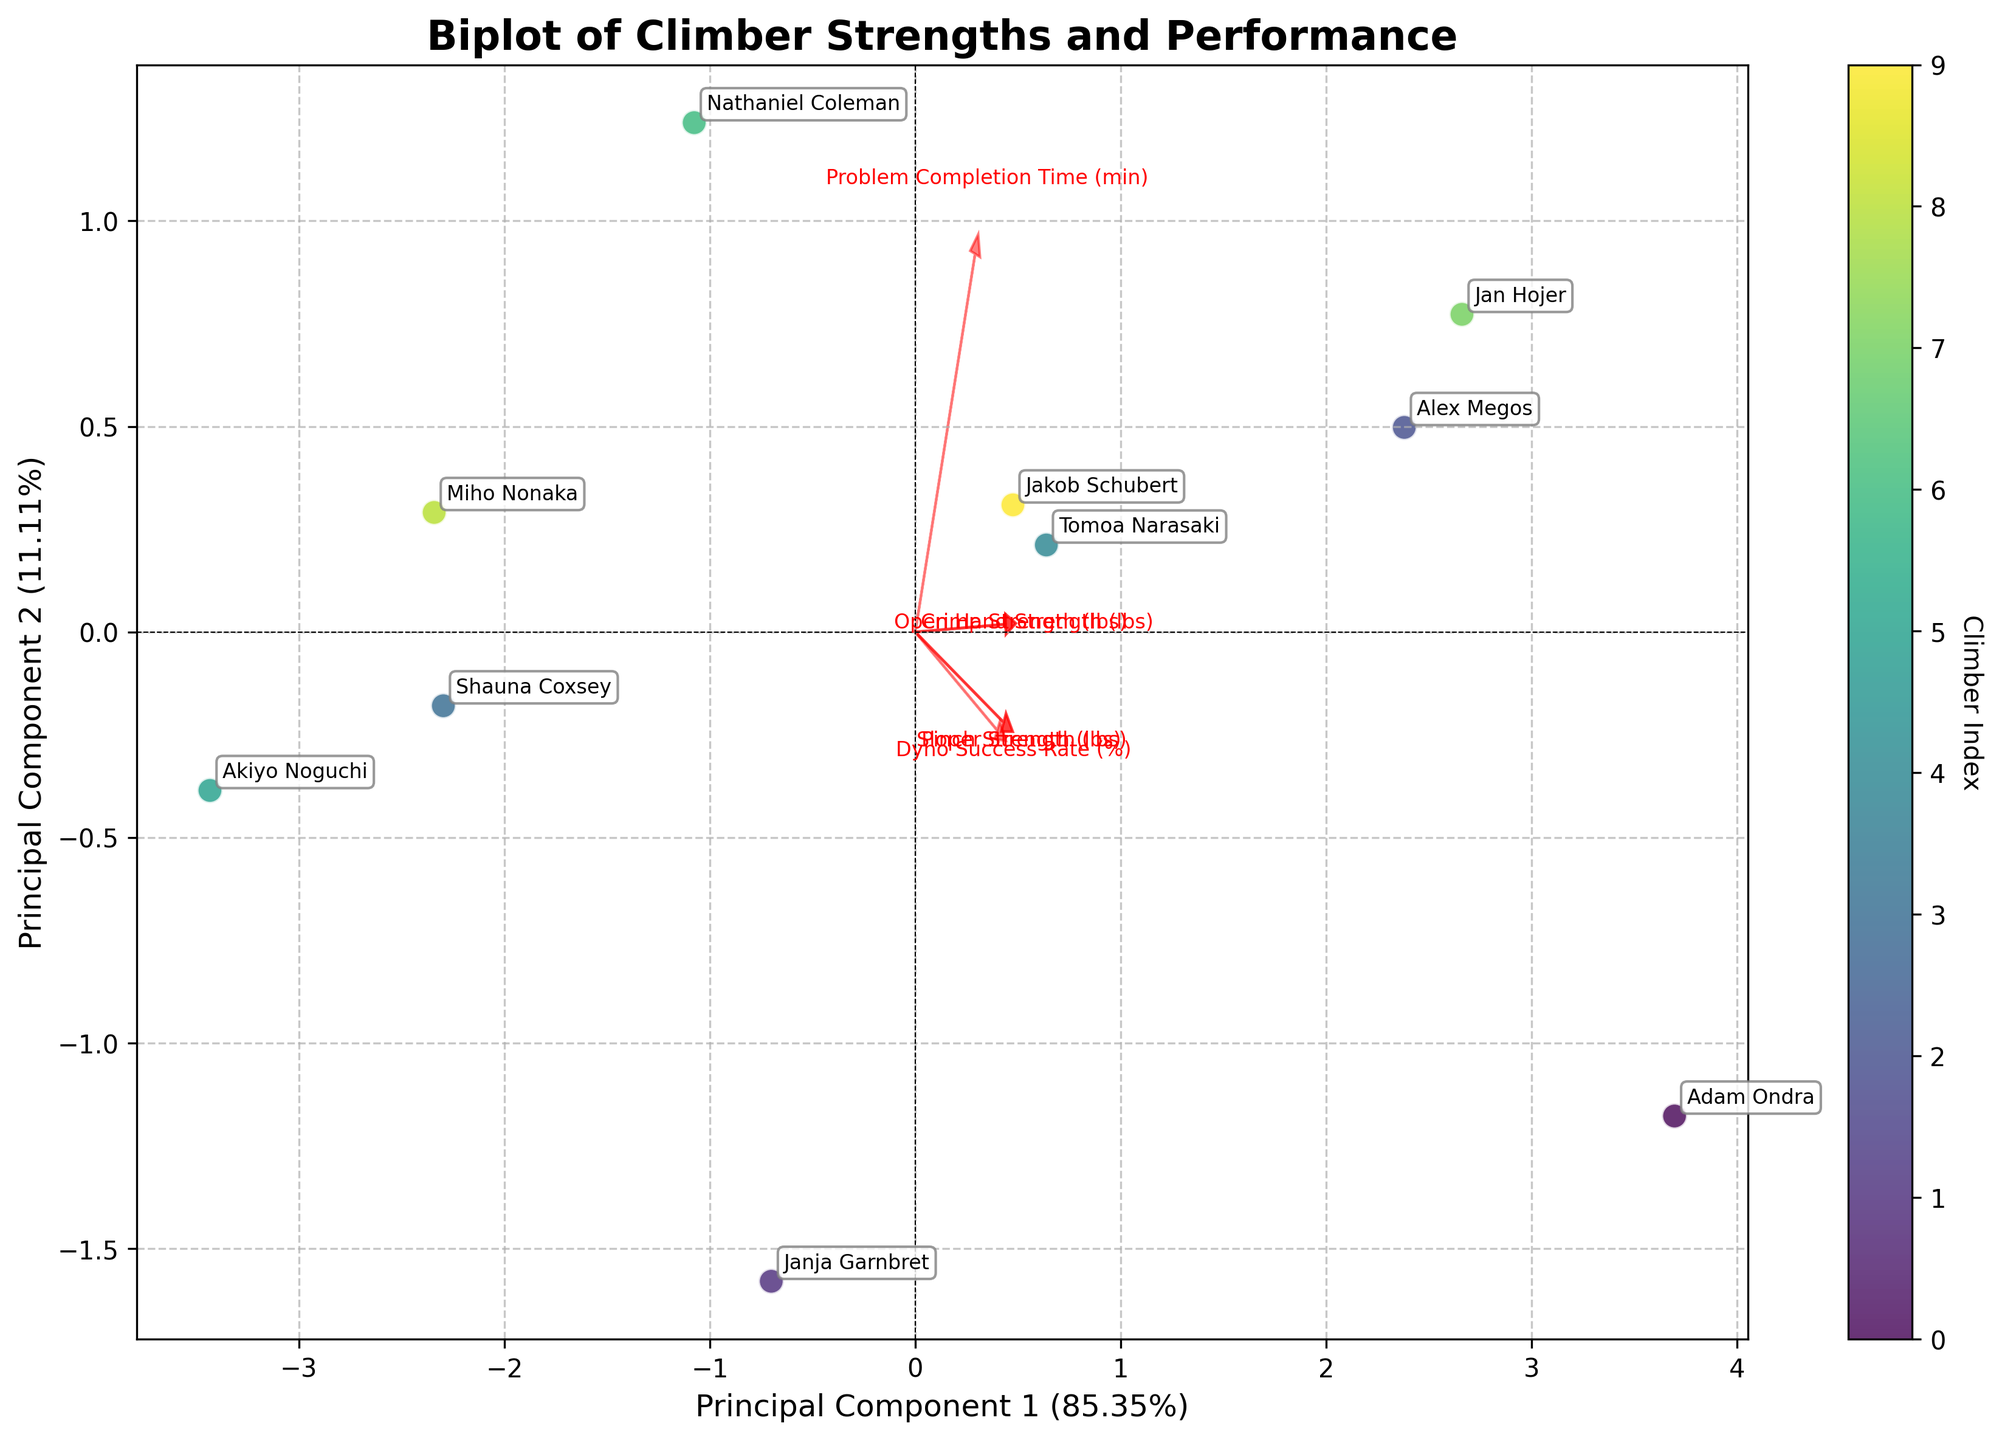What is the title of the biplot? The title of the biplot is typically displayed at the top of the figure to summarize its content. It helps viewers quickly understand what the plot is about.
Answer: Biplot of Climber Strengths and Performance How many climbers are represented in the plot? The plot includes points for each climber, and by counting the annotated names, we can determine the number of climbers.
Answer: 10 Which principal component explains the most variance in the data? The x-axis and y-axis labels indicate the percentage of variance explained by each principal component. By comparing these percentages, we can identify which one explains the most variance.
Answer: Principal Component 1 What features have high positive loading on Principal Component 1? Features with arrows pointing predominantly in the direction of Principal Component 1 on the x-axis have high positive loadings on this component. Identify the features from their labels.
Answer: Crimp Strength (lbs) and Dyno Success Rate (%) Which climber has the highest Principal Component 1 value? By locating the data point farthest to the right on the Principal Component 1 axis and noting the associated climber's name, we can identify the climber.
Answer: Adam Ondra Compare the positions of Adam Ondra and Janja Garnbret in the plot. How are they different or similar based on Principal Component 2? By observing the vertical positions of the data points for Adam Ondra and Janja Garnbret, we can infer information about their scores on Principal Component 2.
Answer: Adam Ondra is positioned higher than Janja Garnbret on Principal Component 2 Which feature vectors point in the same general direction as Principal Component 2? Feature vectors pointing predominantly along the y-axis and towards the positive direction align with Principal Component 2. Identify these features by their labels.
Answer: Open Hand Strength (lbs) and Problem Completion Time (min) How are Crimp Strength (lbs) and Sloper Strength (lbs) related according to the biplot? By examining the angles between the feature vectors, we can infer their relationships. Vectors pointing in roughly the same direction indicate positive correlation.
Answer: Positively correlated Which climber seems to balance all strength and performance features most evenly? A data point located near the origin suggests balanced scores across multiple features, considering the loadings of each feature vector. Identify the closest climber.
Answer: Miho Nonaka 